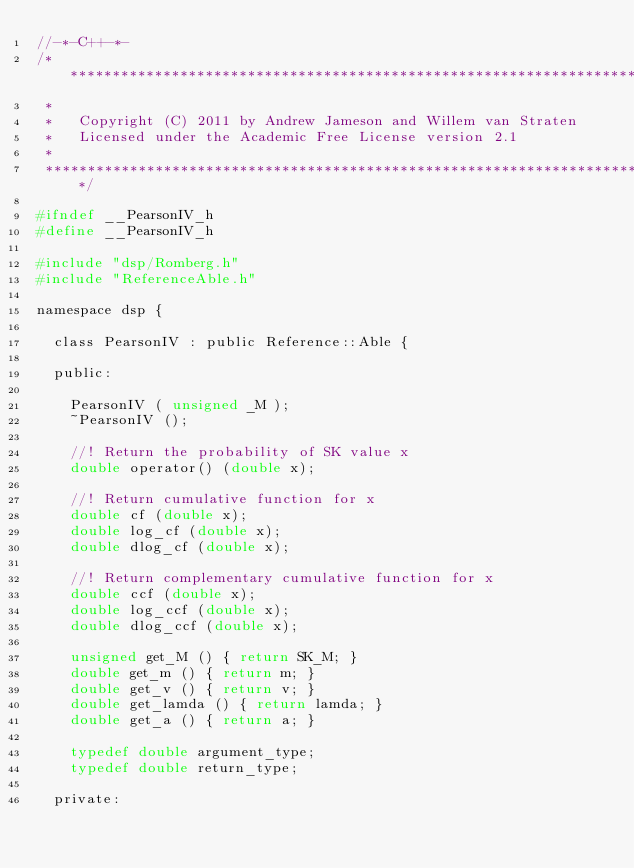<code> <loc_0><loc_0><loc_500><loc_500><_C_>//-*-C++-*-
/***************************************************************************
 *
 *   Copyright (C) 2011 by Andrew Jameson and Willem van Straten
 *   Licensed under the Academic Free License version 2.1
 *
 ***************************************************************************/

#ifndef __PearsonIV_h
#define __PearsonIV_h

#include "dsp/Romberg.h"
#include "ReferenceAble.h"

namespace dsp {

  class PearsonIV : public Reference::Able {

  public:

    PearsonIV ( unsigned _M );
    ~PearsonIV ();

    //! Return the probability of SK value x
    double operator() (double x);

    //! Return cumulative function for x
    double cf (double x);
    double log_cf (double x);
    double dlog_cf (double x);

    //! Return complementary cumulative function for x
    double ccf (double x);
    double log_ccf (double x);
    double dlog_ccf (double x);

    unsigned get_M () { return SK_M; }
    double get_m () { return m; }
    double get_v () { return v; }
    double get_lamda () { return lamda; }
    double get_a () { return a; }
      
    typedef double argument_type;
    typedef double return_type;

  private:
</code> 